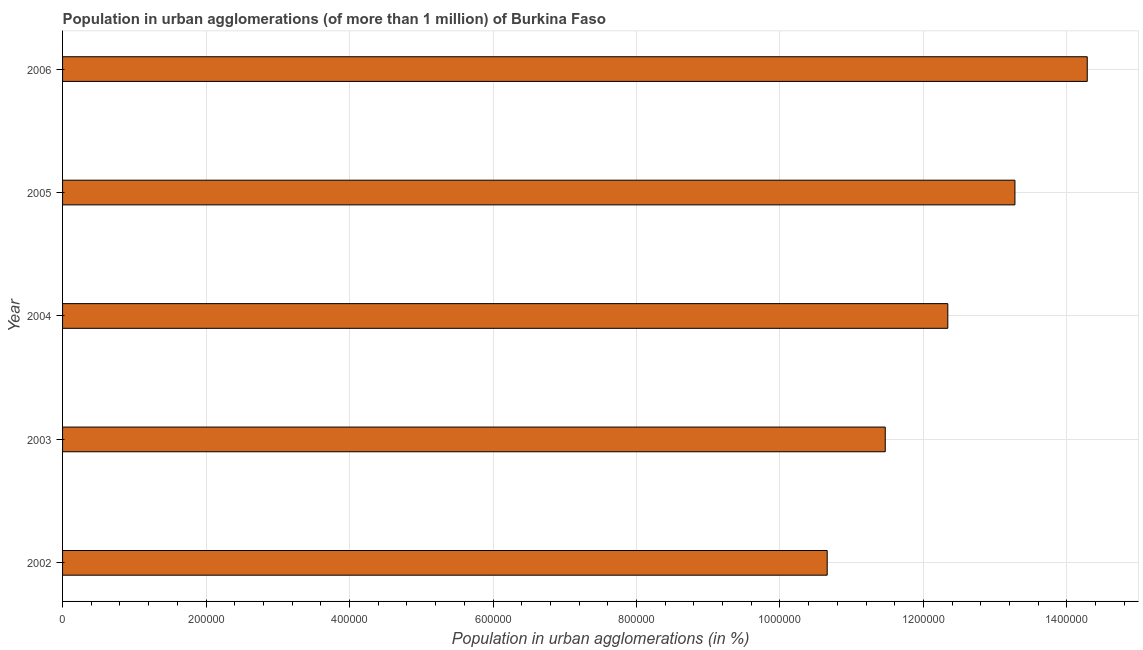Does the graph contain any zero values?
Ensure brevity in your answer.  No. Does the graph contain grids?
Offer a terse response. Yes. What is the title of the graph?
Provide a succinct answer. Population in urban agglomerations (of more than 1 million) of Burkina Faso. What is the label or title of the X-axis?
Give a very brief answer. Population in urban agglomerations (in %). What is the label or title of the Y-axis?
Keep it short and to the point. Year. What is the population in urban agglomerations in 2004?
Ensure brevity in your answer.  1.23e+06. Across all years, what is the maximum population in urban agglomerations?
Your answer should be very brief. 1.43e+06. Across all years, what is the minimum population in urban agglomerations?
Keep it short and to the point. 1.07e+06. In which year was the population in urban agglomerations minimum?
Provide a succinct answer. 2002. What is the sum of the population in urban agglomerations?
Keep it short and to the point. 6.20e+06. What is the difference between the population in urban agglomerations in 2003 and 2004?
Give a very brief answer. -8.72e+04. What is the average population in urban agglomerations per year?
Keep it short and to the point. 1.24e+06. What is the median population in urban agglomerations?
Your response must be concise. 1.23e+06. Do a majority of the years between 2002 and 2004 (inclusive) have population in urban agglomerations greater than 480000 %?
Your answer should be very brief. Yes. What is the ratio of the population in urban agglomerations in 2003 to that in 2005?
Give a very brief answer. 0.86. Is the difference between the population in urban agglomerations in 2003 and 2006 greater than the difference between any two years?
Give a very brief answer. No. What is the difference between the highest and the second highest population in urban agglomerations?
Make the answer very short. 1.01e+05. Is the sum of the population in urban agglomerations in 2003 and 2005 greater than the maximum population in urban agglomerations across all years?
Your answer should be compact. Yes. What is the difference between the highest and the lowest population in urban agglomerations?
Your answer should be compact. 3.63e+05. In how many years, is the population in urban agglomerations greater than the average population in urban agglomerations taken over all years?
Your response must be concise. 2. Are all the bars in the graph horizontal?
Give a very brief answer. Yes. Are the values on the major ticks of X-axis written in scientific E-notation?
Your response must be concise. No. What is the Population in urban agglomerations (in %) of 2002?
Keep it short and to the point. 1.07e+06. What is the Population in urban agglomerations (in %) of 2003?
Provide a short and direct response. 1.15e+06. What is the Population in urban agglomerations (in %) of 2004?
Your answer should be very brief. 1.23e+06. What is the Population in urban agglomerations (in %) in 2005?
Your response must be concise. 1.33e+06. What is the Population in urban agglomerations (in %) in 2006?
Offer a terse response. 1.43e+06. What is the difference between the Population in urban agglomerations (in %) in 2002 and 2003?
Provide a succinct answer. -8.09e+04. What is the difference between the Population in urban agglomerations (in %) in 2002 and 2004?
Provide a succinct answer. -1.68e+05. What is the difference between the Population in urban agglomerations (in %) in 2002 and 2005?
Offer a very short reply. -2.62e+05. What is the difference between the Population in urban agglomerations (in %) in 2002 and 2006?
Your response must be concise. -3.63e+05. What is the difference between the Population in urban agglomerations (in %) in 2003 and 2004?
Your answer should be compact. -8.72e+04. What is the difference between the Population in urban agglomerations (in %) in 2003 and 2005?
Your answer should be very brief. -1.81e+05. What is the difference between the Population in urban agglomerations (in %) in 2003 and 2006?
Your response must be concise. -2.82e+05. What is the difference between the Population in urban agglomerations (in %) in 2004 and 2005?
Give a very brief answer. -9.36e+04. What is the difference between the Population in urban agglomerations (in %) in 2004 and 2006?
Your response must be concise. -1.94e+05. What is the difference between the Population in urban agglomerations (in %) in 2005 and 2006?
Your response must be concise. -1.01e+05. What is the ratio of the Population in urban agglomerations (in %) in 2002 to that in 2003?
Your answer should be very brief. 0.93. What is the ratio of the Population in urban agglomerations (in %) in 2002 to that in 2004?
Provide a succinct answer. 0.86. What is the ratio of the Population in urban agglomerations (in %) in 2002 to that in 2005?
Offer a terse response. 0.8. What is the ratio of the Population in urban agglomerations (in %) in 2002 to that in 2006?
Your answer should be compact. 0.75. What is the ratio of the Population in urban agglomerations (in %) in 2003 to that in 2004?
Provide a succinct answer. 0.93. What is the ratio of the Population in urban agglomerations (in %) in 2003 to that in 2005?
Your answer should be compact. 0.86. What is the ratio of the Population in urban agglomerations (in %) in 2003 to that in 2006?
Provide a short and direct response. 0.8. What is the ratio of the Population in urban agglomerations (in %) in 2004 to that in 2005?
Provide a short and direct response. 0.93. What is the ratio of the Population in urban agglomerations (in %) in 2004 to that in 2006?
Ensure brevity in your answer.  0.86. What is the ratio of the Population in urban agglomerations (in %) in 2005 to that in 2006?
Provide a succinct answer. 0.93. 